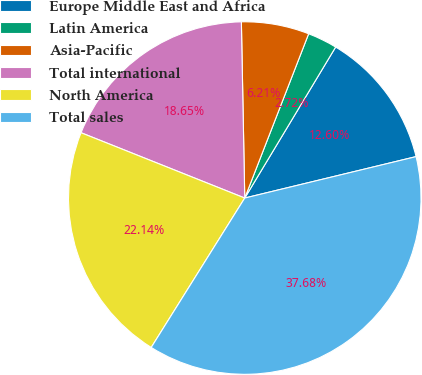Convert chart. <chart><loc_0><loc_0><loc_500><loc_500><pie_chart><fcel>Europe Middle East and Africa<fcel>Latin America<fcel>Asia-Pacific<fcel>Total international<fcel>North America<fcel>Total sales<nl><fcel>12.6%<fcel>2.72%<fcel>6.21%<fcel>18.65%<fcel>22.14%<fcel>37.68%<nl></chart> 